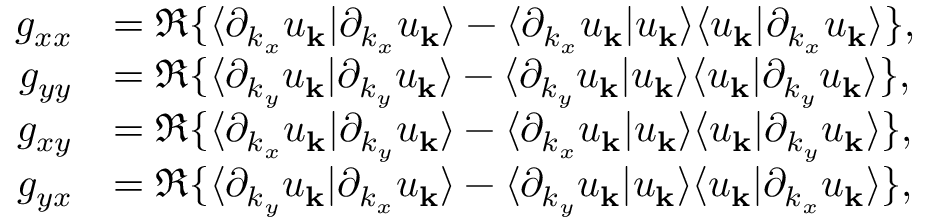<formula> <loc_0><loc_0><loc_500><loc_500>\begin{array} { r l } { g _ { x x } } & { = \Re \{ \langle \partial _ { k _ { x } } u _ { k } | \partial _ { k _ { x } } u _ { k } \rangle - \langle \partial _ { k _ { x } } u _ { k } | u _ { k } \rangle \langle u _ { k } | \partial _ { k _ { x } } u _ { k } \rangle \} , } \\ { g _ { y y } } & { = \Re \{ \langle \partial _ { k _ { y } } u _ { k } | \partial _ { k _ { y } } u _ { k } \rangle - \langle \partial _ { k _ { y } } u _ { k } | u _ { k } \rangle \langle u _ { k } | \partial _ { k _ { y } } u _ { k } \rangle \} , } \\ { g _ { x y } } & { = \Re \{ \langle \partial _ { k _ { x } } u _ { k } | \partial _ { k _ { y } } u _ { k } \rangle - \langle \partial _ { k _ { x } } u _ { k } | u _ { k } \rangle \langle u _ { k } | \partial _ { k _ { y } } u _ { k } \rangle \} , } \\ { g _ { y x } } & { = \Re \{ \langle \partial _ { k _ { y } } u _ { k } | \partial _ { k _ { x } } u _ { k } \rangle - \langle \partial _ { k _ { y } } u _ { k } | u _ { k } \rangle \langle u _ { k } | \partial _ { k _ { x } } u _ { k } \rangle \} , } \end{array}</formula> 